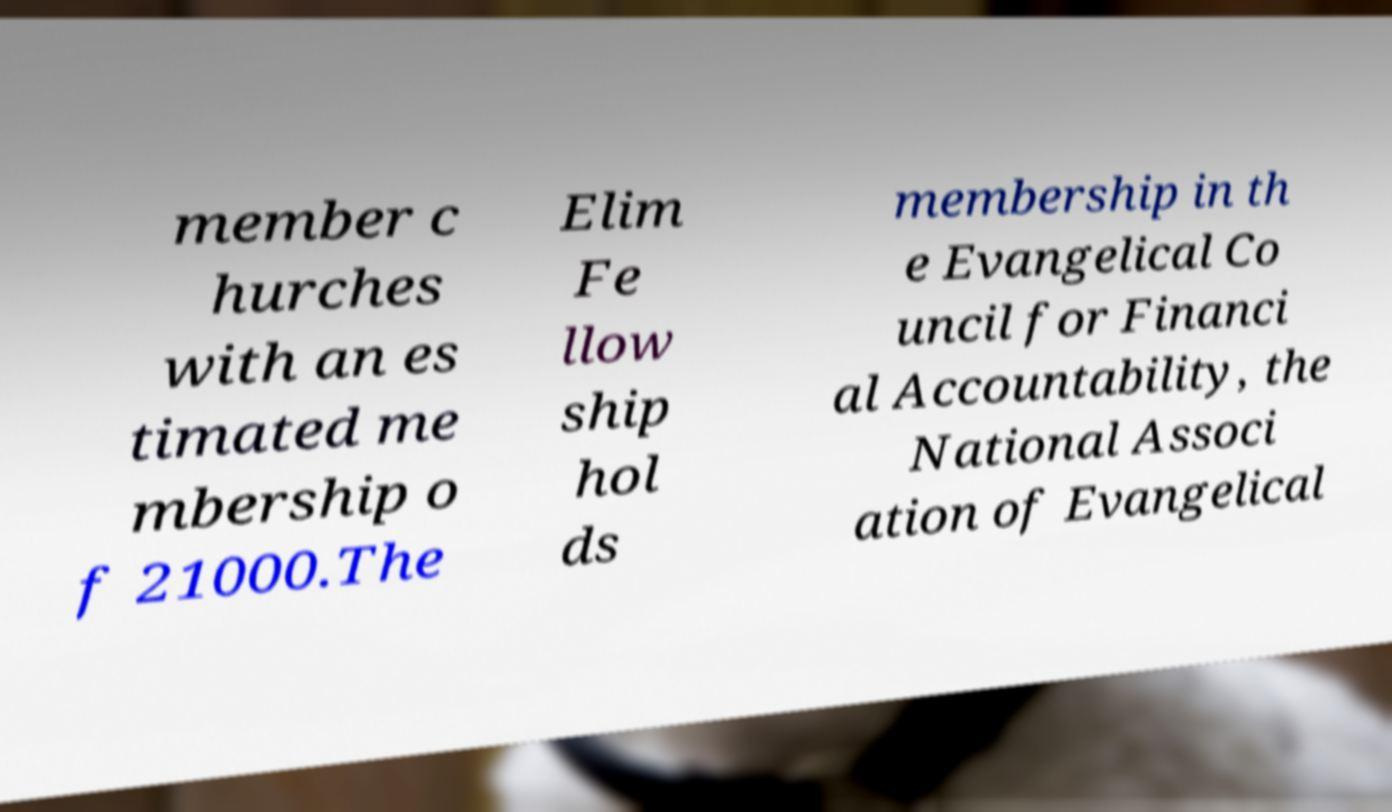I need the written content from this picture converted into text. Can you do that? member c hurches with an es timated me mbership o f 21000.The Elim Fe llow ship hol ds membership in th e Evangelical Co uncil for Financi al Accountability, the National Associ ation of Evangelical 